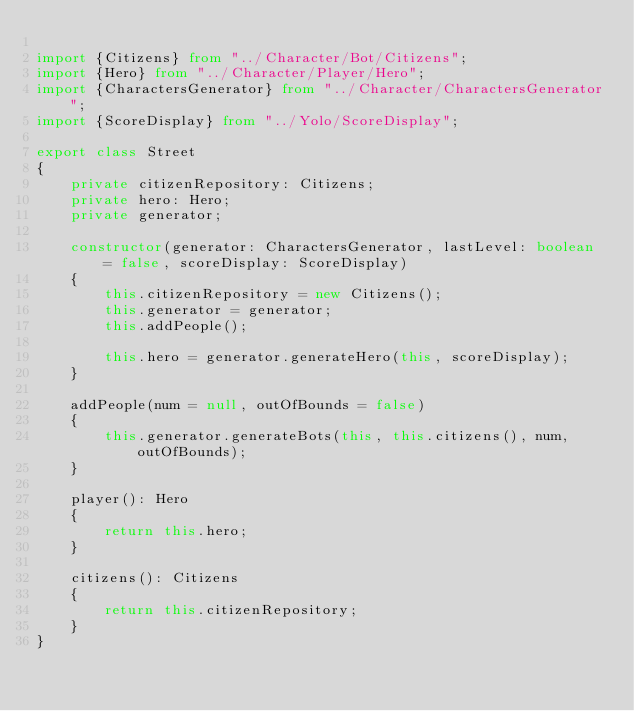Convert code to text. <code><loc_0><loc_0><loc_500><loc_500><_TypeScript_>
import {Citizens} from "../Character/Bot/Citizens";
import {Hero} from "../Character/Player/Hero";
import {CharactersGenerator} from "../Character/CharactersGenerator";
import {ScoreDisplay} from "../Yolo/ScoreDisplay";

export class Street
{
    private citizenRepository: Citizens;
    private hero: Hero;
    private generator;

    constructor(generator: CharactersGenerator, lastLevel: boolean = false, scoreDisplay: ScoreDisplay)
    {
        this.citizenRepository = new Citizens();
        this.generator = generator;
        this.addPeople();

        this.hero = generator.generateHero(this, scoreDisplay);
    }

    addPeople(num = null, outOfBounds = false)
    {
        this.generator.generateBots(this, this.citizens(), num, outOfBounds);
    }

    player(): Hero
    {
        return this.hero;
    }

    citizens(): Citizens
    {
        return this.citizenRepository;
    }
}
</code> 